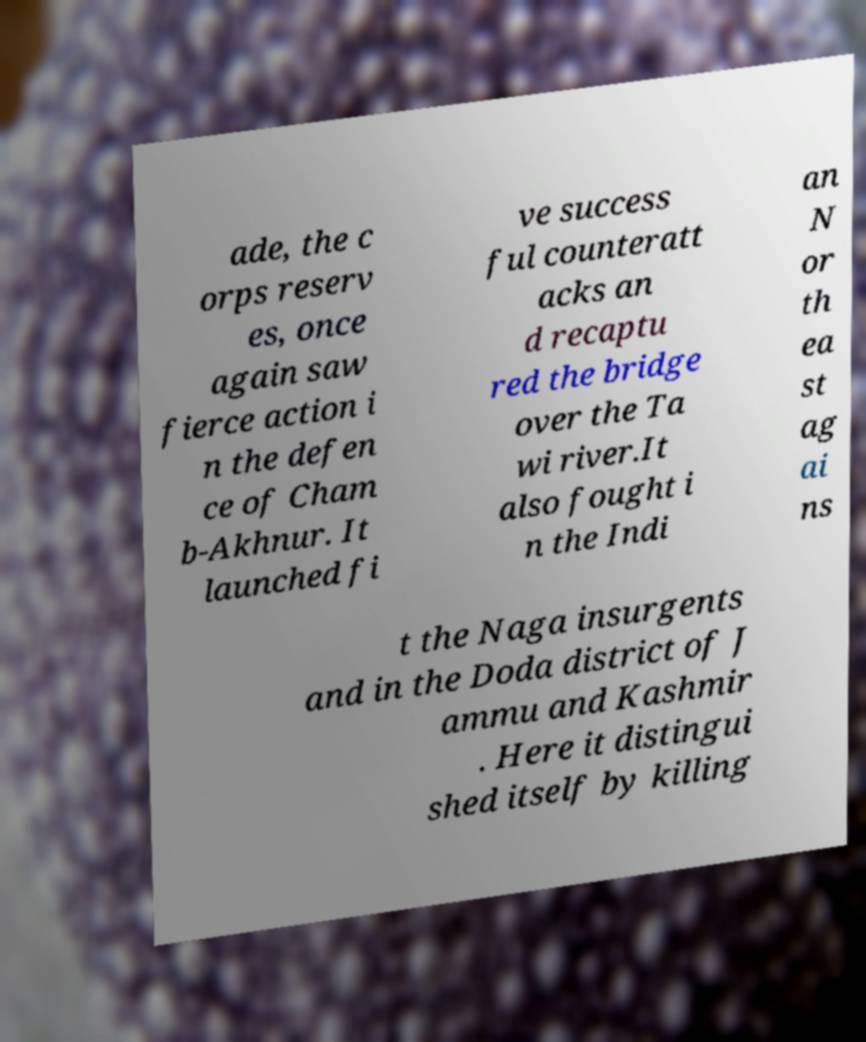What messages or text are displayed in this image? I need them in a readable, typed format. ade, the c orps reserv es, once again saw fierce action i n the defen ce of Cham b-Akhnur. It launched fi ve success ful counteratt acks an d recaptu red the bridge over the Ta wi river.It also fought i n the Indi an N or th ea st ag ai ns t the Naga insurgents and in the Doda district of J ammu and Kashmir . Here it distingui shed itself by killing 